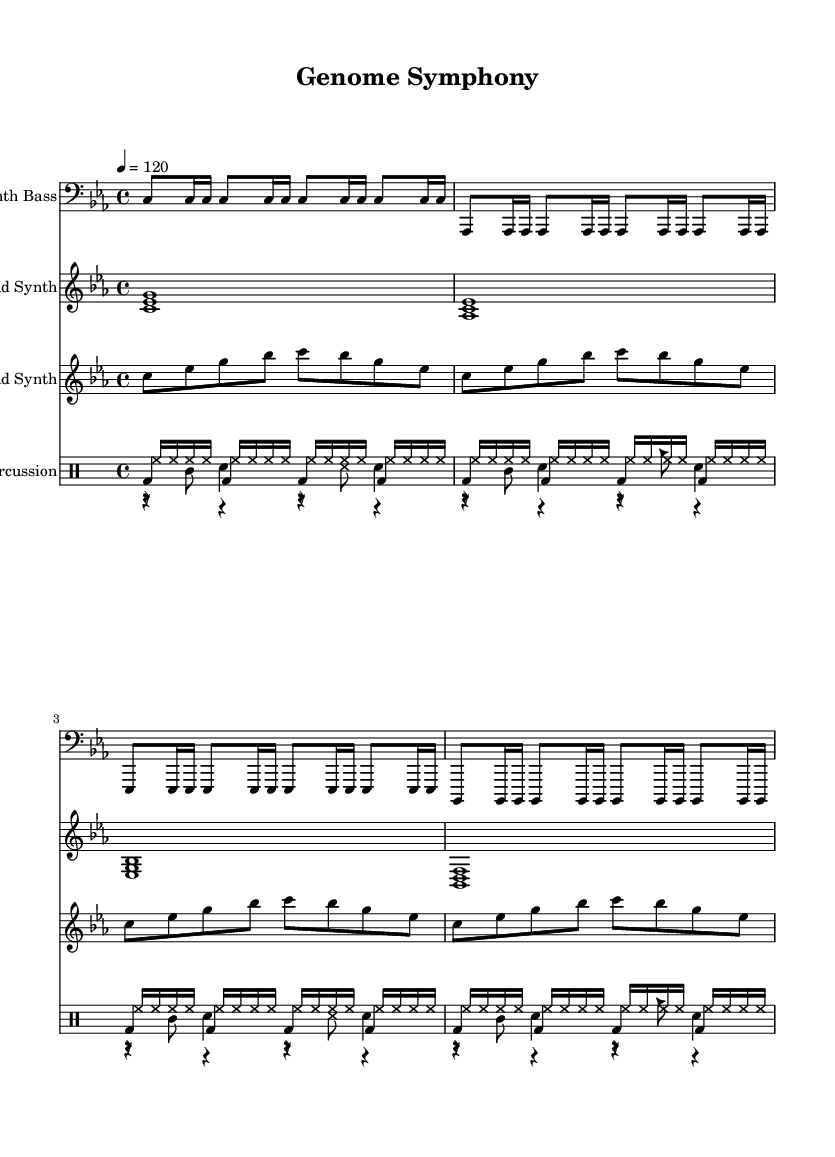What is the key signature of this music? The key signature is C minor, which includes three flats (B♭, E♭, A♭). This can be found at the beginning of the sheet music where the key signature is indicated.
Answer: C minor What is the time signature of this composition? The time signature is 4/4, which means there are four beats in each measure. This is indicated at the beginning of the music where the time signature is shown.
Answer: 4/4 What is the tempo marking for the piece? The tempo marking is 120 beats per minute, expressed as "4 = 120". This indicates how fast the piece should be played, which is specified at the start of the music.
Answer: 120 How many measures does the kick drum pattern last? The kick drum pattern is in four measures, indicated by the grouping and the repetition of the pattern across the sections, shown in the drum notation.
Answer: 4 Which instrument plays the lead synth part? The lead synthesizer part is played by "Lead Synth," as indicated by the staff label in the music. This clarifies which voice in the score corresponds to the lead synthesizer sound.
Answer: Lead Synth What types of sounds are included in the percussion section? The percussion section includes kick drum, snare drum, hi-hat, and glitch sounds. Each type of sound is represented by its respective notation in the drum staff.
Answer: Kick drum, snare drum, hi-hat, glitch sounds How is the bass represented in this score? The bass is represented by the "Synth Bass" part, which contains a series of notes in the bass clef. This clarifies which lines and spaces correspond to the bass sounds within the composition.
Answer: Synth Bass 